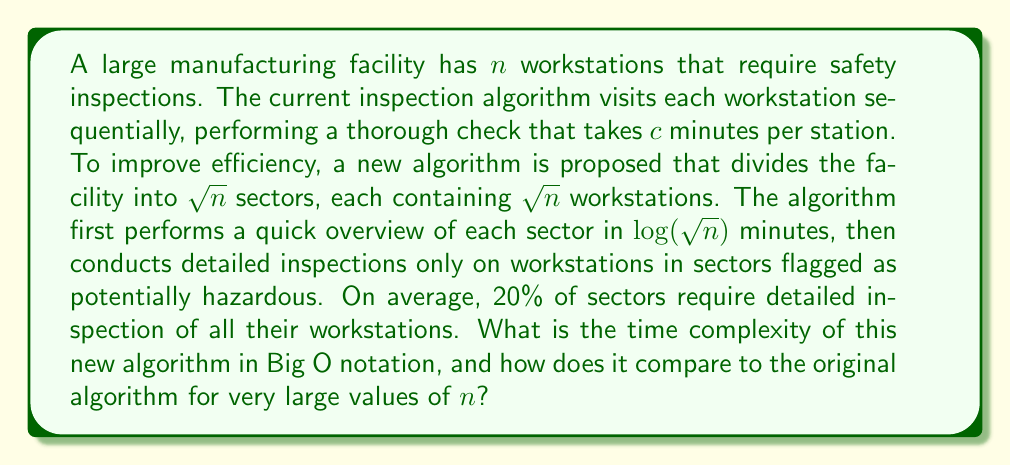Could you help me with this problem? Let's analyze the time complexity of both algorithms:

1. Original Algorithm:
   - Visits all $n$ workstations
   - Takes $c$ minutes per station
   - Total time: $T_1(n) = cn$
   - Time complexity: $O(n)$

2. New Algorithm:
   Step 1: Quick overview of sectors
   - Number of sectors: $\sqrt{n}$
   - Time per sector overview: $\log(\sqrt{n}) = \frac{1}{2}\log(n)$
   - Total time for overviews: $T_{2a}(n) = \sqrt{n} \cdot \frac{1}{2}\log(n) = \frac{1}{2}\sqrt{n}\log(n)$

   Step 2: Detailed inspection of flagged sectors
   - Number of flagged sectors (20%): $0.2\sqrt{n}$
   - Workstations per sector: $\sqrt{n}$
   - Time per workstation: $c$ minutes
   - Total time for detailed inspections: $T_{2b}(n) = 0.2\sqrt{n} \cdot \sqrt{n} \cdot c = 0.2cn$

   Total time for new algorithm: $T_2(n) = T_{2a}(n) + T_{2b}(n) = \frac{1}{2}\sqrt{n}\log(n) + 0.2cn$

   The dominant term for large $n$ is $\frac{1}{2}\sqrt{n}\log(n)$, so the time complexity is $O(\sqrt{n}\log(n))$.

Comparing the two algorithms for very large $n$:
$O(\sqrt{n}\log(n))$ grows more slowly than $O(n)$, making the new algorithm more efficient for large facilities.
Answer: The time complexity of the new algorithm is $O(\sqrt{n}\log(n))$, which is more efficient than the original $O(n)$ algorithm for very large values of $n$. 